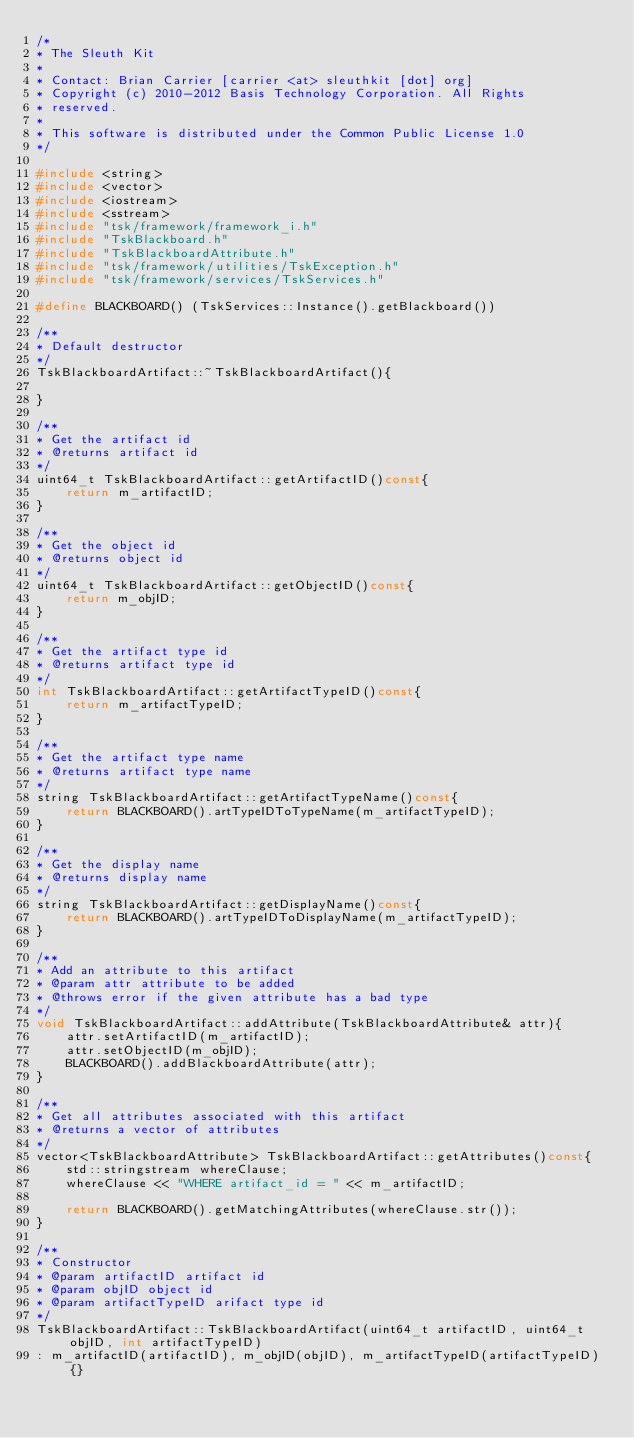<code> <loc_0><loc_0><loc_500><loc_500><_C++_>/*
* The Sleuth Kit
*
* Contact: Brian Carrier [carrier <at> sleuthkit [dot] org]
* Copyright (c) 2010-2012 Basis Technology Corporation. All Rights
* reserved.
*
* This software is distributed under the Common Public License 1.0
*/

#include <string>
#include <vector>
#include <iostream>
#include <sstream>
#include "tsk/framework/framework_i.h"
#include "TskBlackboard.h"
#include "TskBlackboardAttribute.h"
#include "tsk/framework/utilities/TskException.h"
#include "tsk/framework/services/TskServices.h"

#define BLACKBOARD() (TskServices::Instance().getBlackboard())

/**
* Default destructor
*/
TskBlackboardArtifact::~TskBlackboardArtifact(){

}

/**
* Get the artifact id
* @returns artifact id
*/
uint64_t TskBlackboardArtifact::getArtifactID()const{
    return m_artifactID;
}

/**
* Get the object id
* @returns object id
*/
uint64_t TskBlackboardArtifact::getObjectID()const{
    return m_objID;
}

/**
* Get the artifact type id
* @returns artifact type id
*/
int TskBlackboardArtifact::getArtifactTypeID()const{
    return m_artifactTypeID;
}

/**
* Get the artifact type name
* @returns artifact type name
*/
string TskBlackboardArtifact::getArtifactTypeName()const{
    return BLACKBOARD().artTypeIDToTypeName(m_artifactTypeID);
}

/**
* Get the display name
* @returns display name
*/
string TskBlackboardArtifact::getDisplayName()const{
    return BLACKBOARD().artTypeIDToDisplayName(m_artifactTypeID);
}

/**
* Add an attribute to this artifact
* @param attr attribute to be added
* @throws error if the given attribute has a bad type
*/
void TskBlackboardArtifact::addAttribute(TskBlackboardAttribute& attr){
    attr.setArtifactID(m_artifactID);
    attr.setObjectID(m_objID);
    BLACKBOARD().addBlackboardAttribute(attr);
}

/**
* Get all attributes associated with this artifact
* @returns a vector of attributes
*/
vector<TskBlackboardAttribute> TskBlackboardArtifact::getAttributes()const{
    std::stringstream whereClause;
    whereClause << "WHERE artifact_id = " << m_artifactID;

    return BLACKBOARD().getMatchingAttributes(whereClause.str());
}

/**
* Constructor
* @param artifactID artifact id 
* @param objID object id 
* @param artifactTypeID arifact type id 
*/	
TskBlackboardArtifact::TskBlackboardArtifact(uint64_t artifactID, uint64_t objID, int artifactTypeID)
: m_artifactID(artifactID), m_objID(objID), m_artifactTypeID(artifactTypeID) {}
</code> 